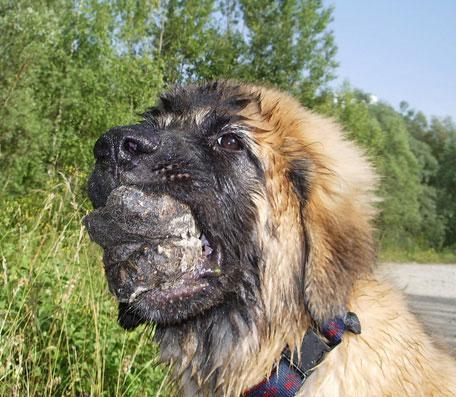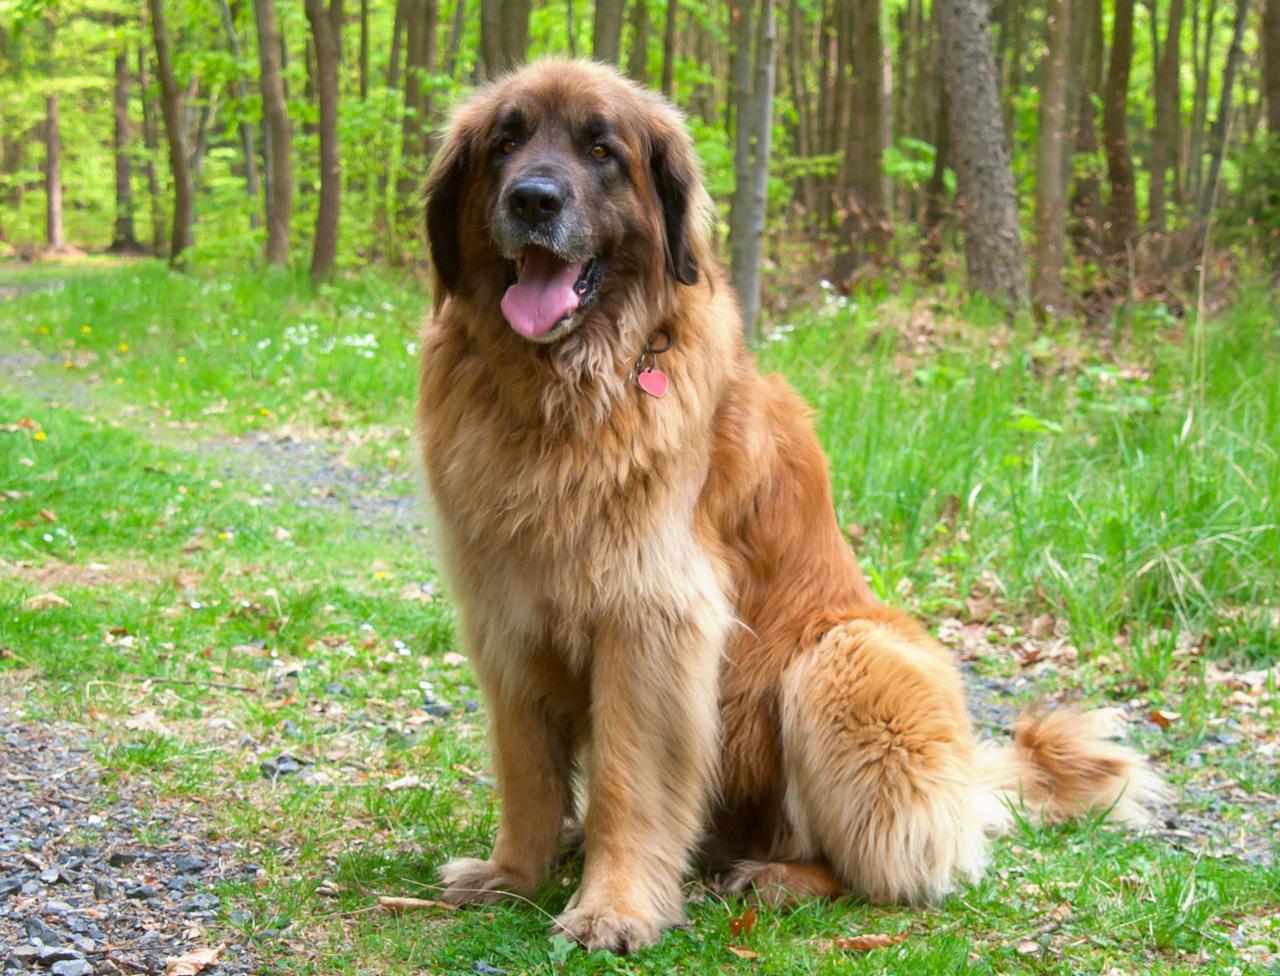The first image is the image on the left, the second image is the image on the right. Considering the images on both sides, is "At least one image shows two mammals." valid? Answer yes or no. No. The first image is the image on the left, the second image is the image on the right. For the images displayed, is the sentence "There is one dog sitting in one image." factually correct? Answer yes or no. Yes. 